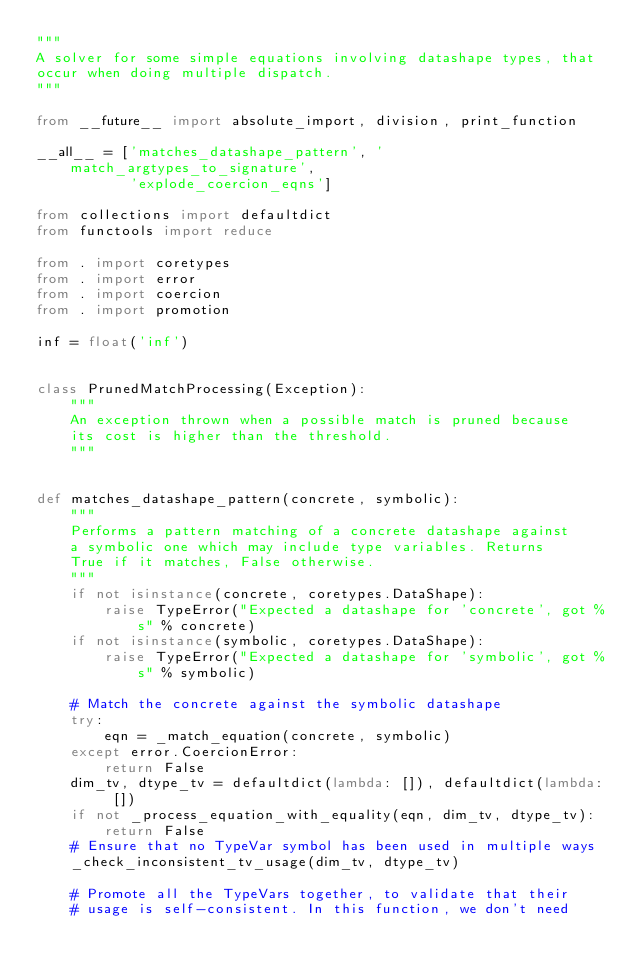Convert code to text. <code><loc_0><loc_0><loc_500><loc_500><_Python_>"""
A solver for some simple equations involving datashape types, that
occur when doing multiple dispatch.
"""

from __future__ import absolute_import, division, print_function

__all__ = ['matches_datashape_pattern', 'match_argtypes_to_signature',
           'explode_coercion_eqns']

from collections import defaultdict
from functools import reduce

from . import coretypes
from . import error
from . import coercion
from . import promotion

inf = float('inf')


class PrunedMatchProcessing(Exception):
    """
    An exception thrown when a possible match is pruned because
    its cost is higher than the threshold.
    """


def matches_datashape_pattern(concrete, symbolic):
    """
    Performs a pattern matching of a concrete datashape against
    a symbolic one which may include type variables. Returns
    True if it matches, False otherwise.
    """
    if not isinstance(concrete, coretypes.DataShape):
        raise TypeError("Expected a datashape for 'concrete', got %s" % concrete)
    if not isinstance(symbolic, coretypes.DataShape):
        raise TypeError("Expected a datashape for 'symbolic', got %s" % symbolic)

    # Match the concrete against the symbolic datashape
    try:
        eqn = _match_equation(concrete, symbolic)
    except error.CoercionError:
        return False
    dim_tv, dtype_tv = defaultdict(lambda: []), defaultdict(lambda: [])
    if not _process_equation_with_equality(eqn, dim_tv, dtype_tv):
        return False
    # Ensure that no TypeVar symbol has been used in multiple ways
    _check_inconsistent_tv_usage(dim_tv, dtype_tv)

    # Promote all the TypeVars together, to validate that their
    # usage is self-consistent. In this function, we don't need</code> 